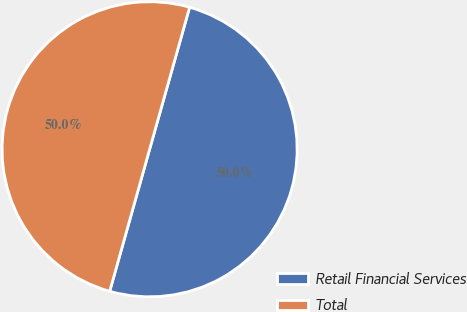<chart> <loc_0><loc_0><loc_500><loc_500><pie_chart><fcel>Retail Financial Services<fcel>Total<nl><fcel>49.99%<fcel>50.01%<nl></chart> 